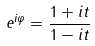Convert formula to latex. <formula><loc_0><loc_0><loc_500><loc_500>e ^ { i \varphi } = \frac { 1 + i t } { 1 - i t }</formula> 